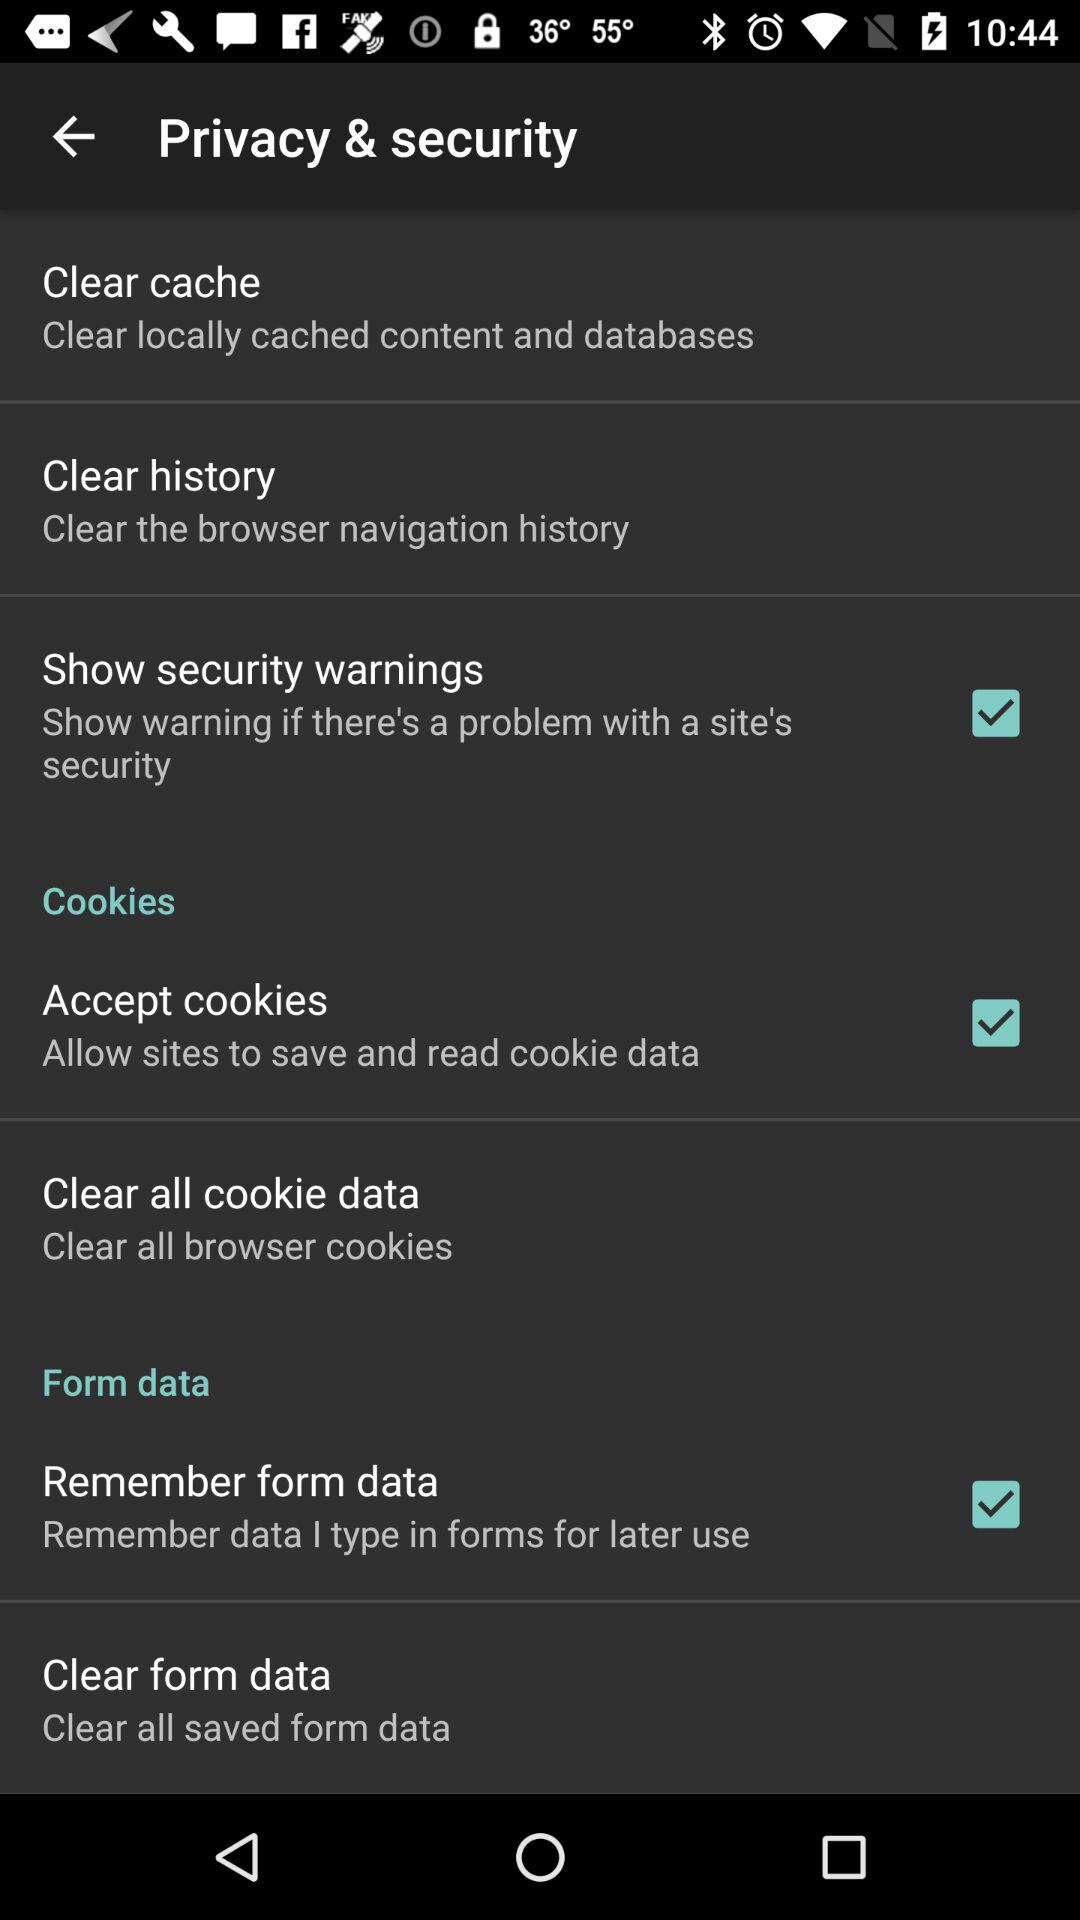What options are selected on the application? The selected options are: "Show security warnings", "Accept cookies", and "Remember form data". 